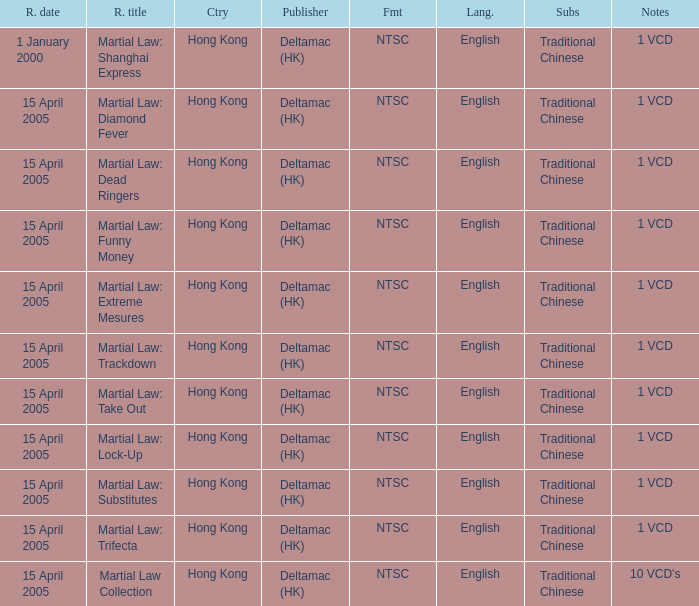Which country had a release of 1 VCD titled Martial Law: Substitutes? Hong Kong. 